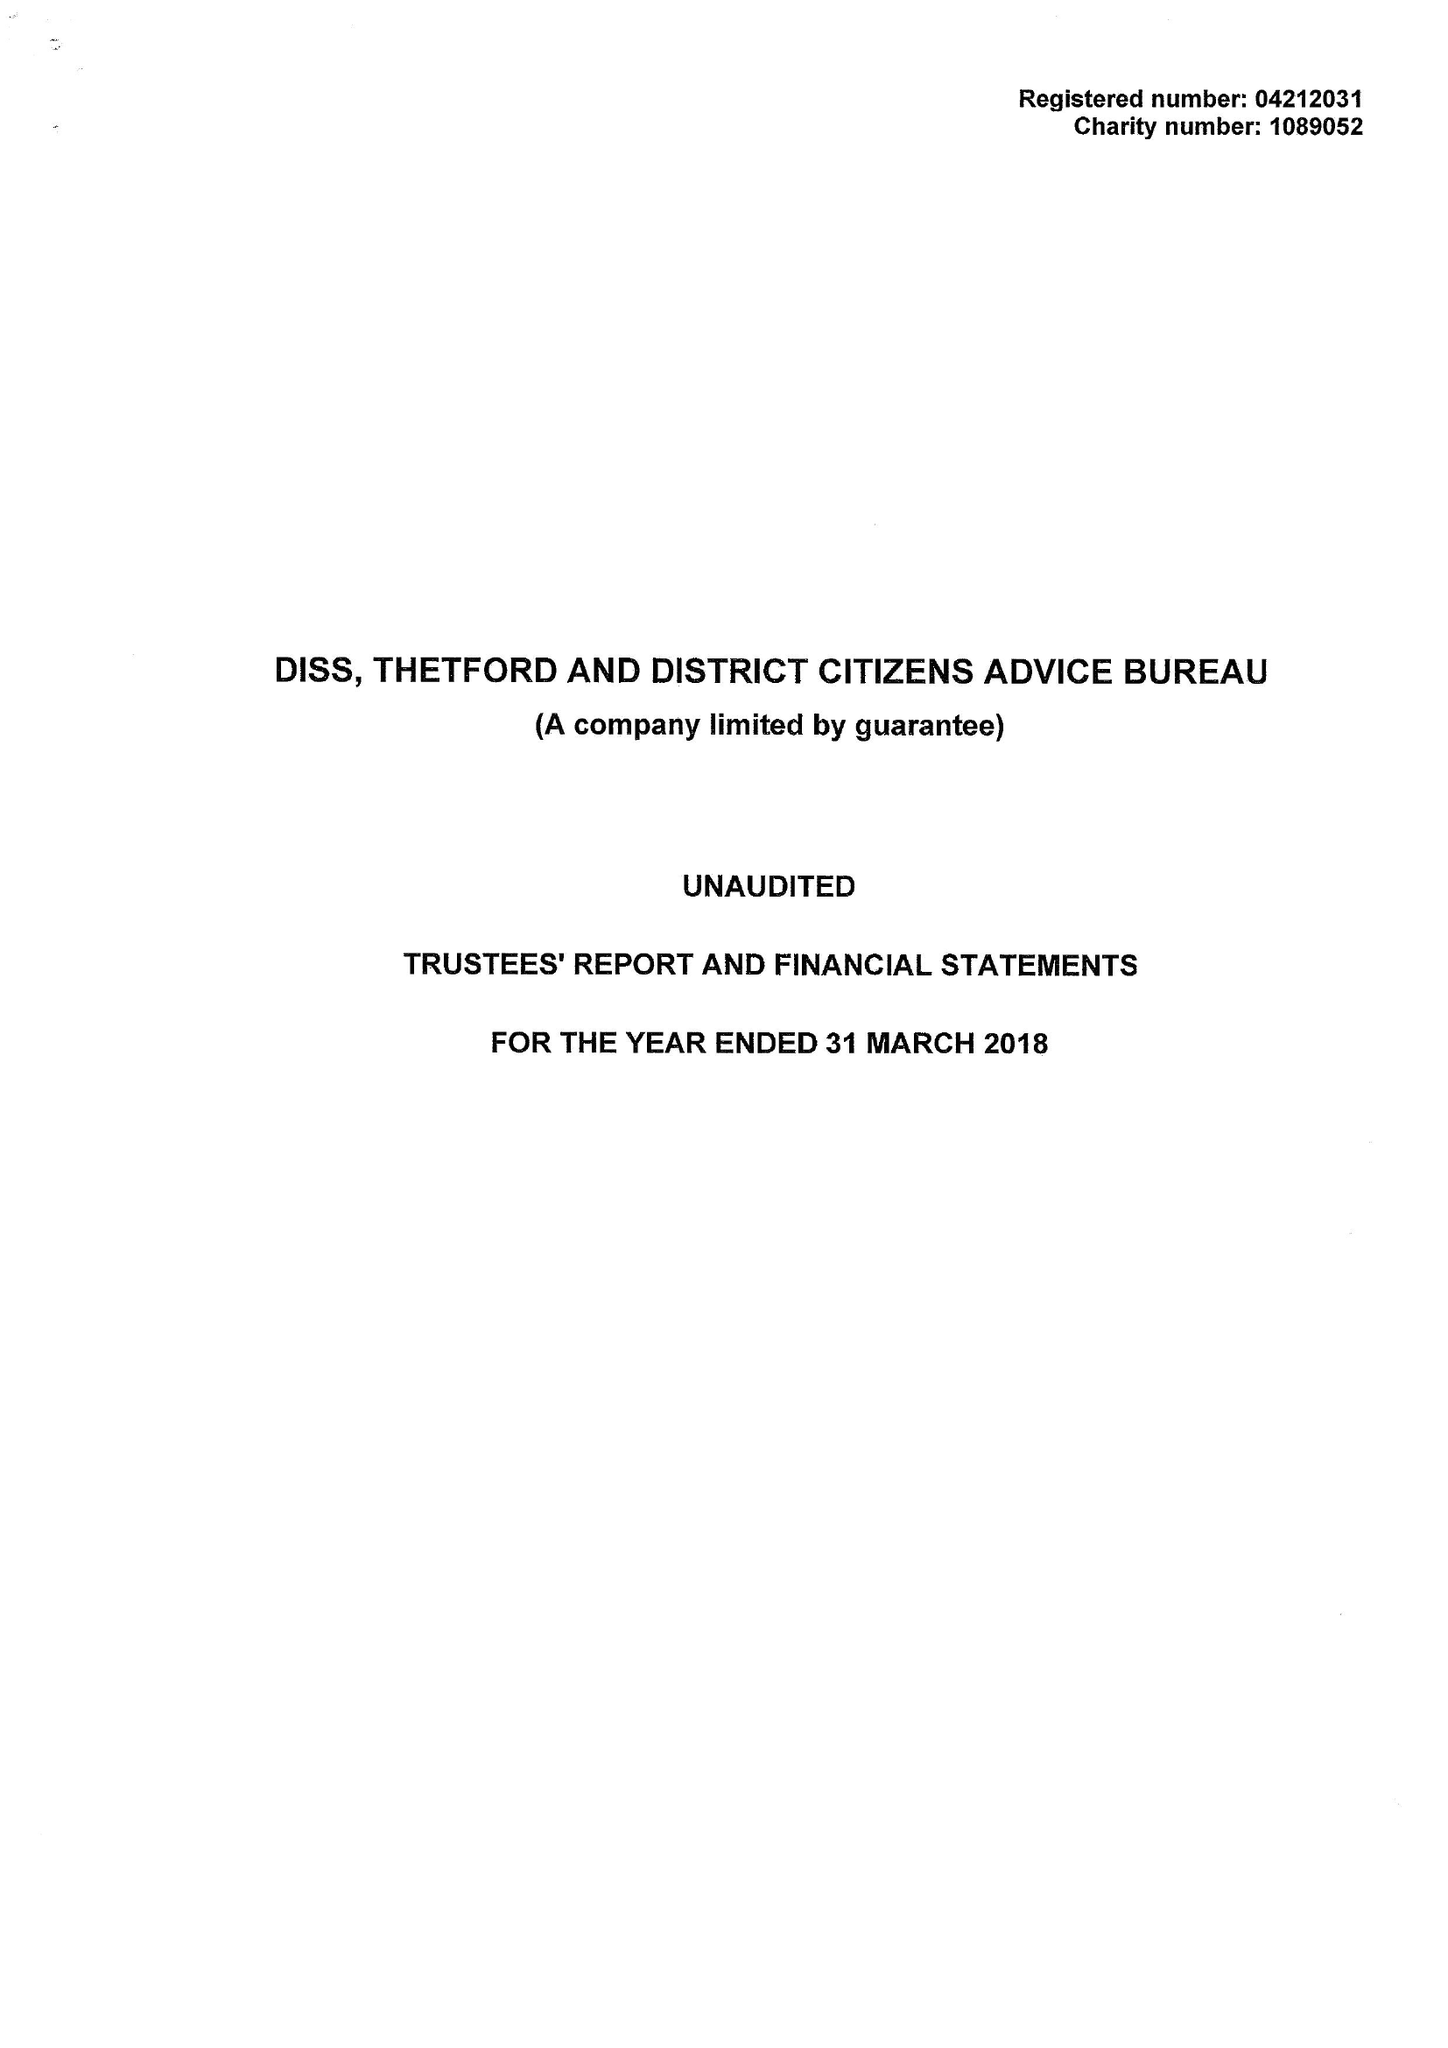What is the value for the spending_annually_in_british_pounds?
Answer the question using a single word or phrase. 344408.00 